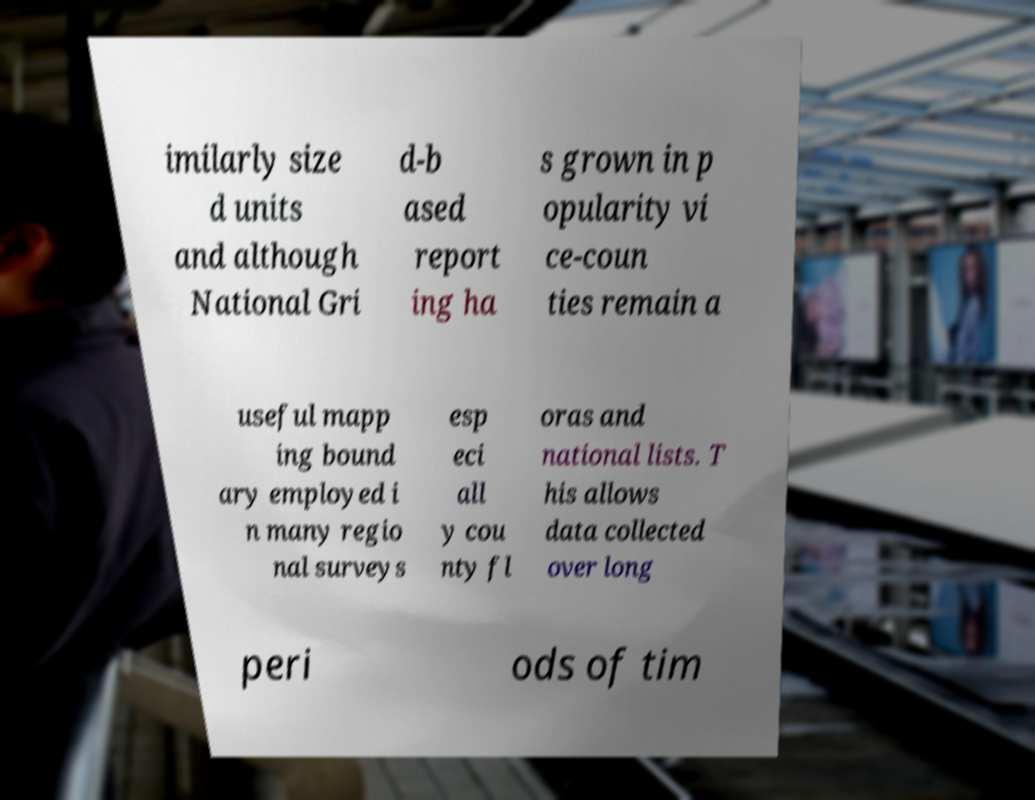For documentation purposes, I need the text within this image transcribed. Could you provide that? imilarly size d units and although National Gri d-b ased report ing ha s grown in p opularity vi ce-coun ties remain a useful mapp ing bound ary employed i n many regio nal surveys esp eci all y cou nty fl oras and national lists. T his allows data collected over long peri ods of tim 